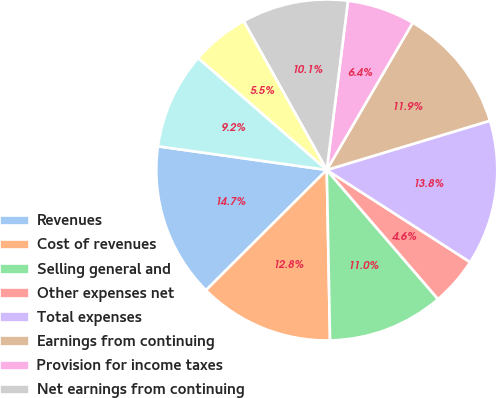Convert chart to OTSL. <chart><loc_0><loc_0><loc_500><loc_500><pie_chart><fcel>Revenues<fcel>Cost of revenues<fcel>Selling general and<fcel>Other expenses net<fcel>Total expenses<fcel>Earnings from continuing<fcel>Provision for income taxes<fcel>Net earnings from continuing<fcel>Earnings (loss) from<fcel>Net earnings<nl><fcel>14.68%<fcel>12.84%<fcel>11.01%<fcel>4.59%<fcel>13.76%<fcel>11.93%<fcel>6.42%<fcel>10.09%<fcel>5.51%<fcel>9.17%<nl></chart> 